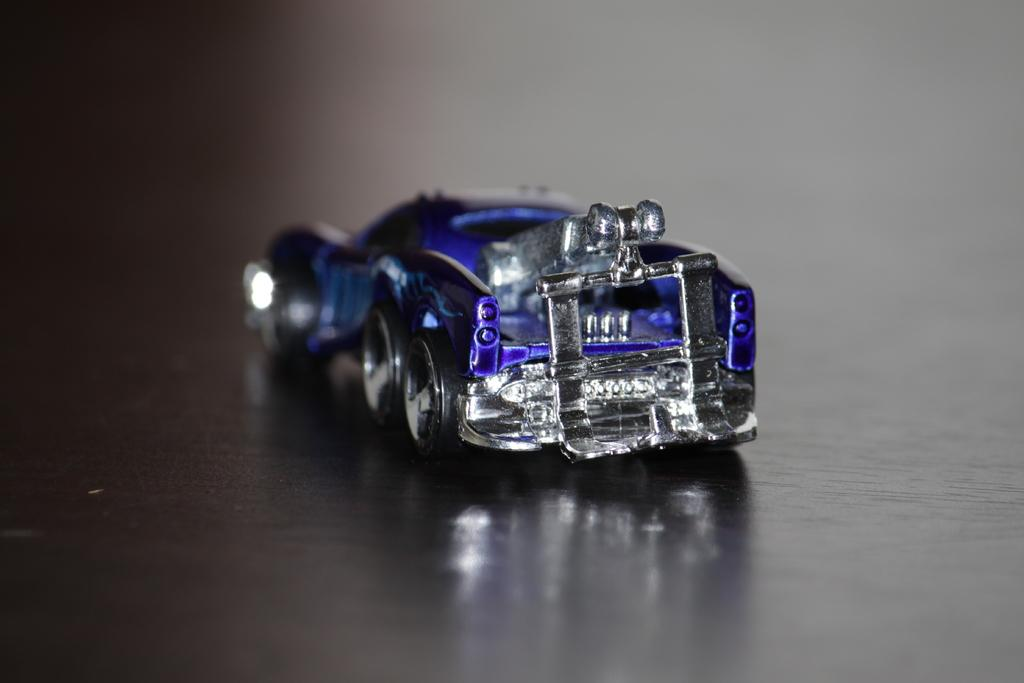What type of toy can be seen in the image? There is a toy car in the image. What piece of furniture is present in the image? There is a table in the image. Can you describe the reflection on the table? There is a reflection of a toy on the table. What type of love can be seen between the toy car and the banana in the image? There is no banana present in the image, and the toy car is an inanimate object, so it cannot experience love. 